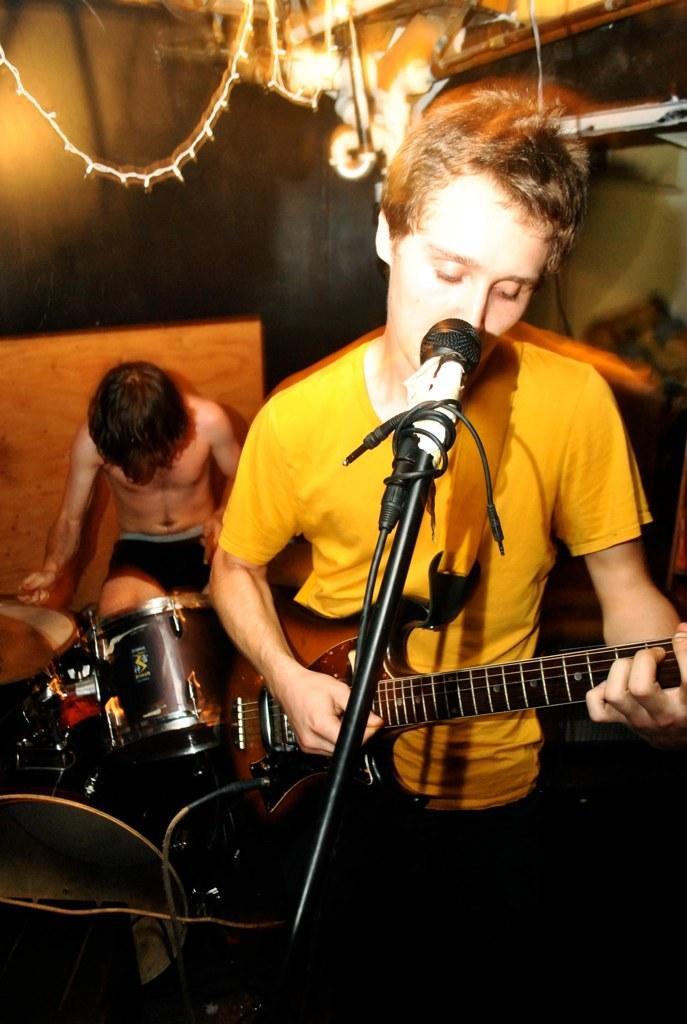Please provide a concise description of this image. In the picture it is a music concert a man wearing yellow shirt is playing the guitar and singing a song behind him there is another person sitting,he is playing drums,to the roof there are different lights in the background there is a wall. 